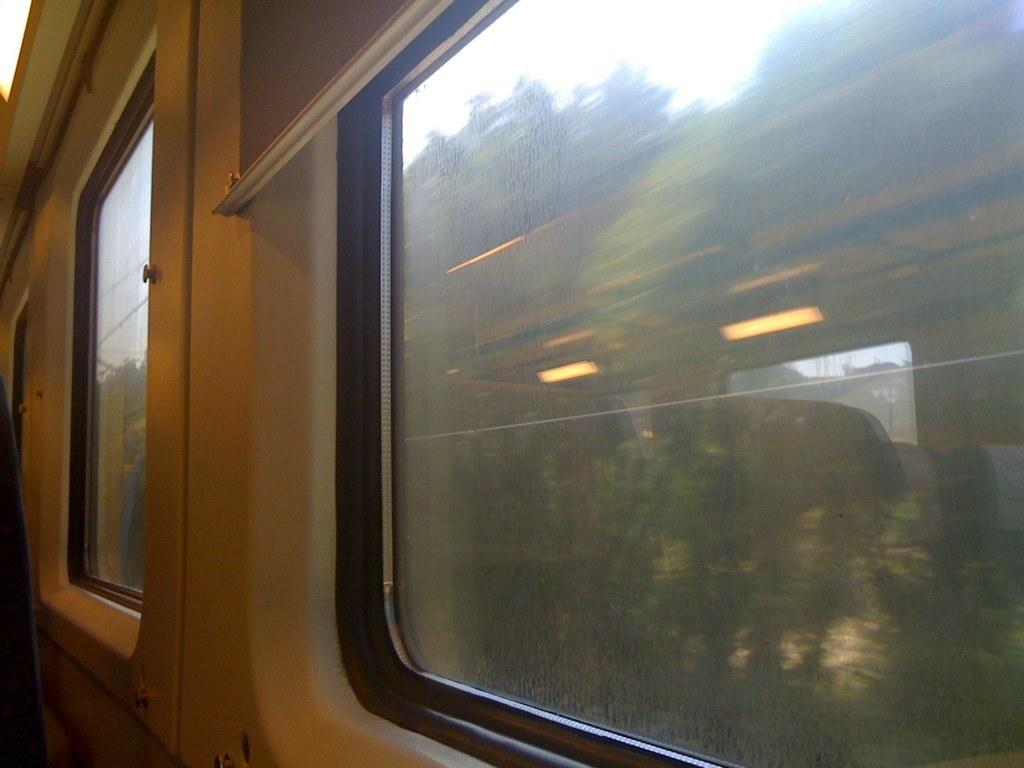What type of material is used for the windows in the image? There are glass windows in the image. What can be seen on the glass windows? The reflection of lights and windows is visible on the glass windows. What type of furniture is present in the image? There are seats in the image. What is visible through the glass windows? Trees and the sky are visible through the glass windows. How many pigs are visible in the image? There are no pigs present in the image. Is there a crook trying to break into the building through the glass windows? There is no crook or any indication of a break-in attempt in the image. 